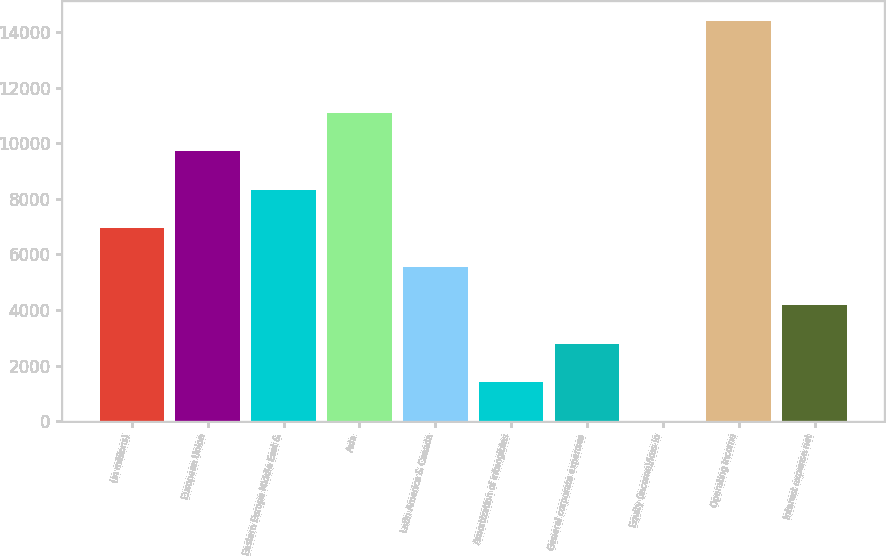Convert chart. <chart><loc_0><loc_0><loc_500><loc_500><bar_chart><fcel>(in millions)<fcel>European Union<fcel>Eastern Europe Middle East &<fcel>Asia<fcel>Latin America & Canada<fcel>Amortization of intangibles<fcel>General corporate expenses<fcel>Equity (income)/loss in<fcel>Operating income<fcel>Interest expense net<nl><fcel>6940<fcel>9709.2<fcel>8324.6<fcel>11093.8<fcel>5555.4<fcel>1401.6<fcel>2786.2<fcel>17<fcel>14388.6<fcel>4170.8<nl></chart> 